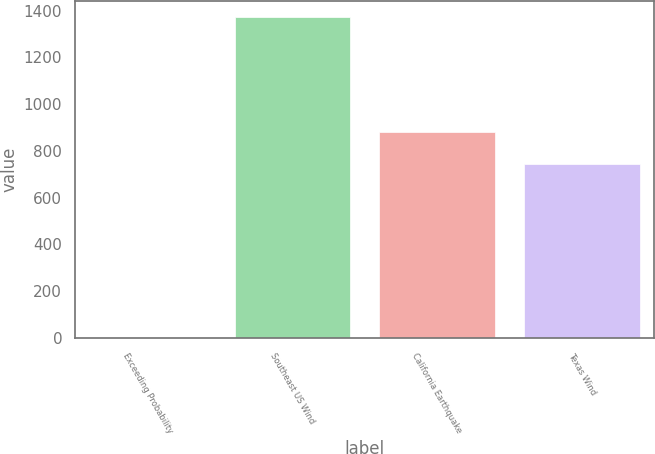<chart> <loc_0><loc_0><loc_500><loc_500><bar_chart><fcel>Exceeding Probability<fcel>Southeast US Wind<fcel>California Earthquake<fcel>Texas Wind<nl><fcel>1<fcel>1371<fcel>880<fcel>743<nl></chart> 